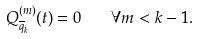<formula> <loc_0><loc_0><loc_500><loc_500>Q _ { \overline { q } _ { k } } ^ { ( m ) } ( t ) = 0 \quad \forall m < k - 1 .</formula> 